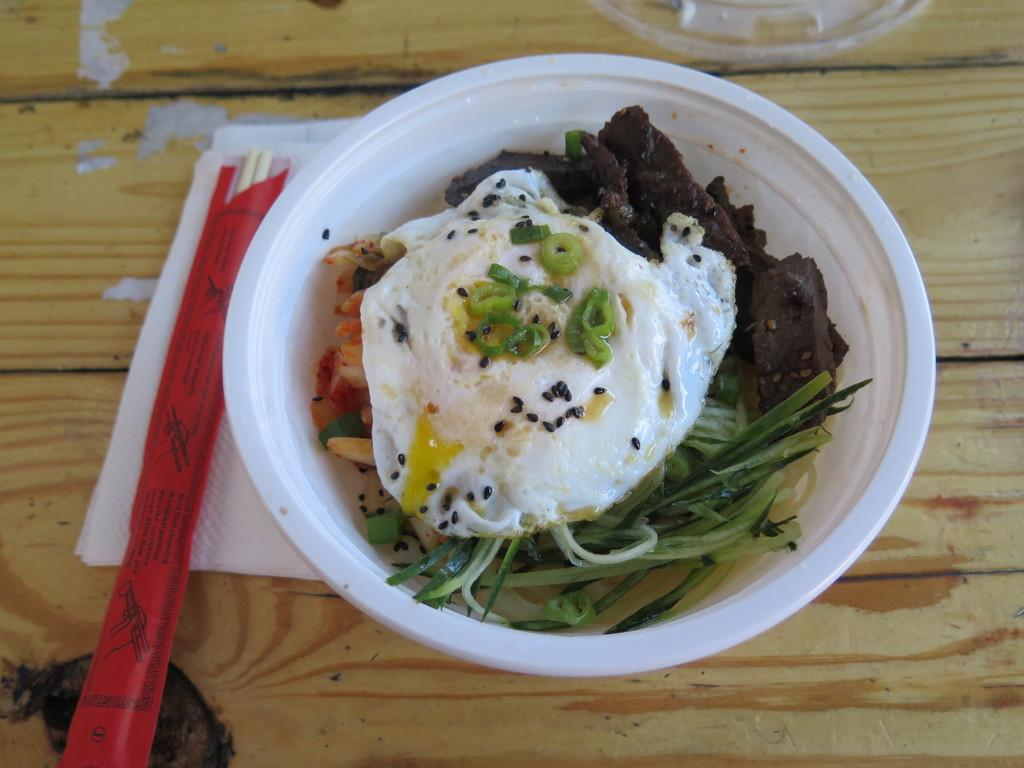What type of table is in the image? There is a wooden table in the image. What is on top of the table? There is a bowl and chopsticks on the table. Are there any additional items on the table? Yes, tissue papers are on the table. What is inside the bowl? The bowl contains food. What time of day is depicted in the image? The image does not provide any information about the time of day, as it only shows a wooden table with a bowl, chopsticks, and tissue papers. 